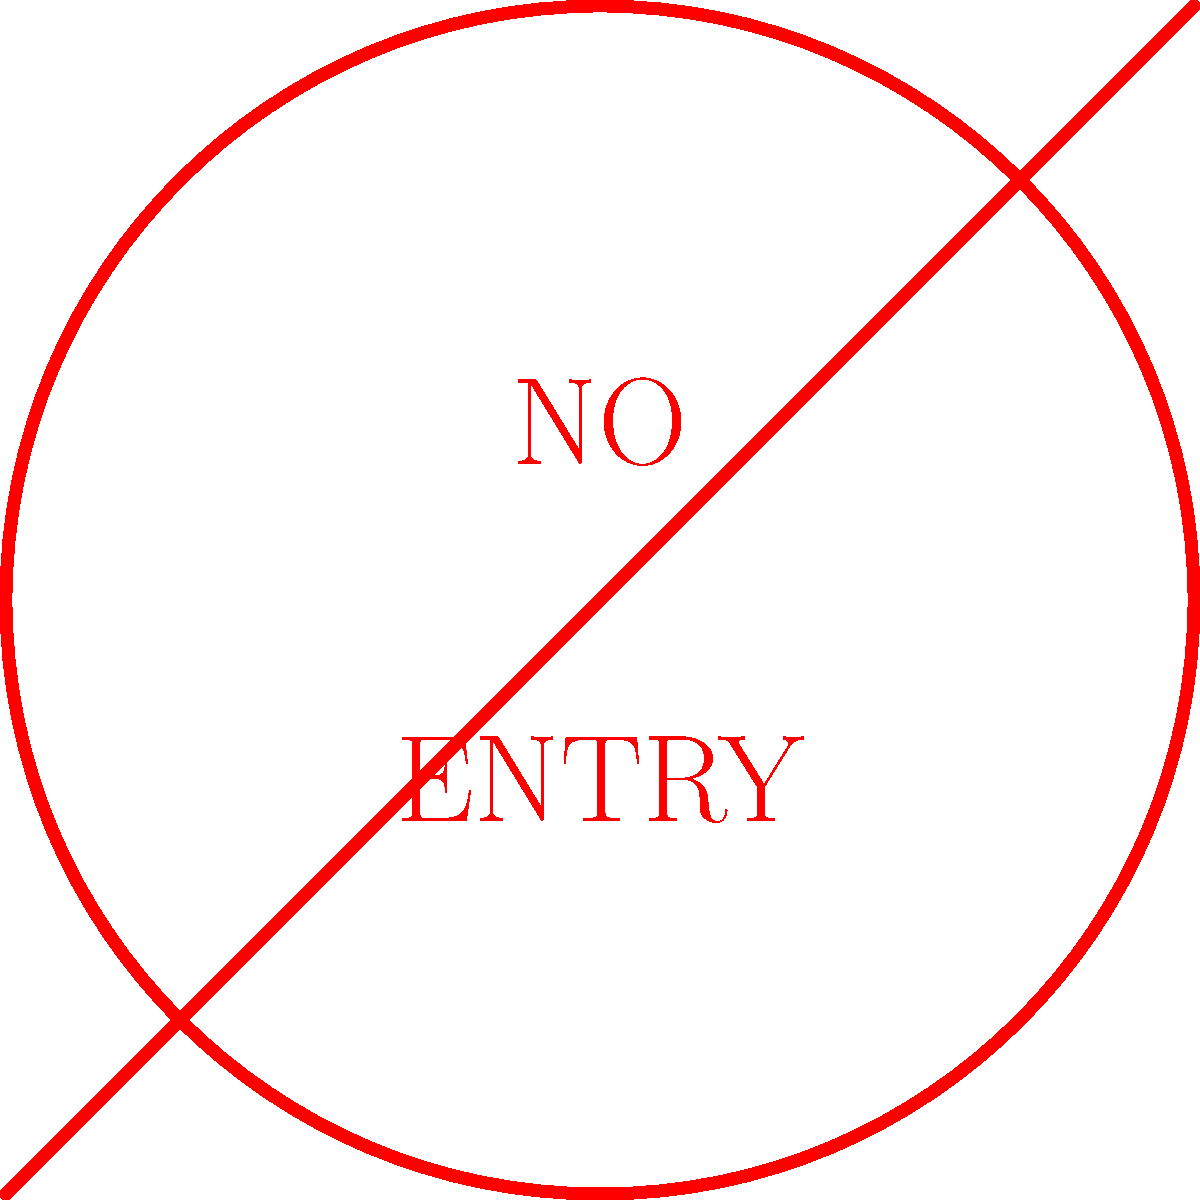You encounter this sign while driving on a rural road in Manitoba. What does it mean, and how should you respond as a responsible driver? 1. Identify the sign: This is a "No Entry" sign, characterized by a red circle with a horizontal red bar across it.

2. Interpret the meaning: This sign indicates that vehicles are not permitted to enter the road or area beyond this point.

3. Understand the context: In rural Manitoba, this sign might be used to indicate:
   a) A one-way street where you're facing the wrong direction
   b) A road closed for construction or maintenance
   c) A private road or area not open to public traffic

4. Proper response:
   a) Do not proceed past this sign under any circumstances
   b) Look for an alternative route or turn around safely
   c) If you're unsure about your location, consult a map or GPS

5. Safety considerations:
   a) Be aware of other vehicles that might be turning around
   b) Check for any additional signs that might provide more information
   c) If the area seems unfamiliar, proceed with caution when finding an alternative route

6. Legal implications: Ignoring this sign and proceeding could result in traffic violations and potential accidents.

As a responsible driver, you should always obey traffic signs to ensure road safety for yourself and others.
Answer: Do not enter; find an alternative route. 